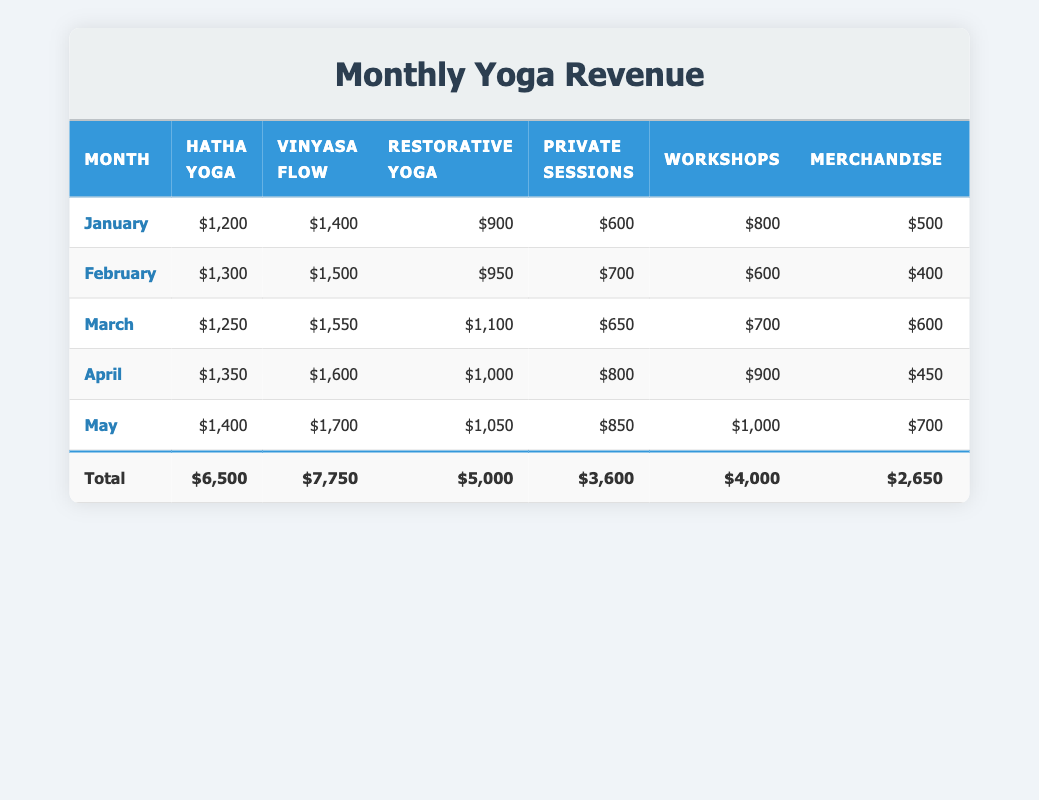What was the total revenue in April? By looking at the 'Total Revenue' column in the row for April, we can directly see that it is $6,200.
Answer: $6,200 Which yoga class generated the most revenue in January? In January, the revenue from each yoga class is listed: Hatha Yoga: $1,200, Vinyasa Flow: $1,400, Restorative Yoga: $900, Private Sessions: $600. The highest amount is from Vinyasa Flow at $1,400.
Answer: Vinyasa Flow What is the average revenue from Workshops over the five months? To find the average, we first sum the revenues from Workshops for each month: $800 + $600 + $700 + $900 + $1,000 = $4,100. Then, we divide by the number of months (5): $4,100 / 5 = $820.
Answer: $820 Did the revenue from May exceed $6,500? The total revenue for May is $7,000, which is greater than $6,500. Therefore, the statement is true.
Answer: Yes Which month saw the highest revenue from Private Sessions? The revenue from Private Sessions for each month is as follows: January: $600, February: $700, March: $650, April: $800, May: $850. The highest revenue is in May at $850.
Answer: May What was the total revenue across all months? To calculate the total revenue, we sum the 'Total Revenue' from each month: January: $5,100 + February: $5,400 + March: $5,900 + April: $6,200 + May: $7,000 = $29,600.
Answer: $29,600 Was the revenue from Restorative Yoga in February less than that in January? The revenue for Restorative Yoga is $950 in February and $900 in January. Therefore, February's revenue was greater than January's.
Answer: No What month experienced the largest increase in total revenue compared to the previous month? By comparing the total revenues month over month: January to February: $5,400 - $5,100 = $300; February to March: $5,900 - $5,400 = $500; March to April: $6,200 - $5,900 = $300; April to May: $7,000 - $6,200 = $800. The largest increase is from April to May.
Answer: April to May 